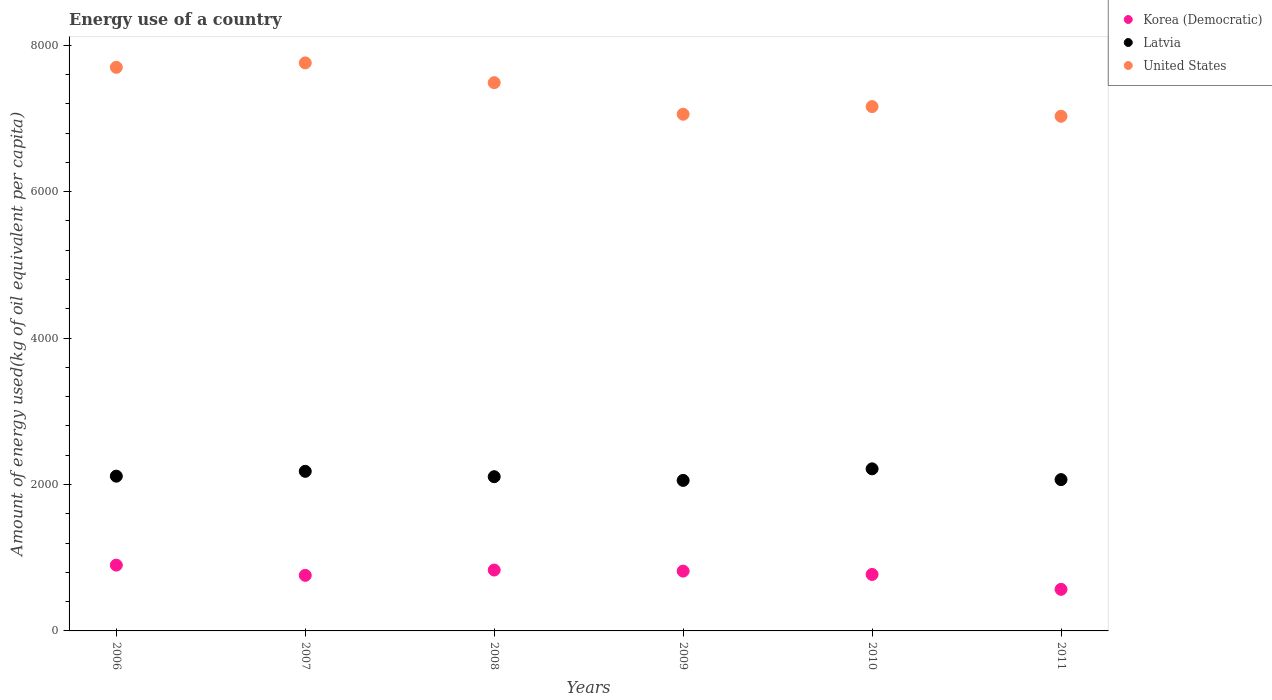What is the amount of energy used in in Korea (Democratic) in 2010?
Your response must be concise. 771.3. Across all years, what is the maximum amount of energy used in in United States?
Ensure brevity in your answer.  7758.17. Across all years, what is the minimum amount of energy used in in United States?
Keep it short and to the point. 7029.18. In which year was the amount of energy used in in Korea (Democratic) maximum?
Ensure brevity in your answer.  2006. What is the total amount of energy used in in Latvia in the graph?
Ensure brevity in your answer.  1.27e+04. What is the difference between the amount of energy used in in Latvia in 2009 and that in 2010?
Ensure brevity in your answer.  -157.81. What is the difference between the amount of energy used in in United States in 2008 and the amount of energy used in in Latvia in 2010?
Offer a terse response. 5274.44. What is the average amount of energy used in in Latvia per year?
Your answer should be compact. 2122.66. In the year 2008, what is the difference between the amount of energy used in in Latvia and amount of energy used in in Korea (Democratic)?
Your response must be concise. 1274.65. In how many years, is the amount of energy used in in Latvia greater than 4400 kg?
Your answer should be very brief. 0. What is the ratio of the amount of energy used in in Korea (Democratic) in 2006 to that in 2010?
Keep it short and to the point. 1.17. What is the difference between the highest and the second highest amount of energy used in in Latvia?
Your answer should be compact. 33.82. What is the difference between the highest and the lowest amount of energy used in in United States?
Offer a terse response. 728.98. In how many years, is the amount of energy used in in Korea (Democratic) greater than the average amount of energy used in in Korea (Democratic) taken over all years?
Keep it short and to the point. 3. Is the sum of the amount of energy used in in Korea (Democratic) in 2006 and 2009 greater than the maximum amount of energy used in in Latvia across all years?
Your response must be concise. No. Is it the case that in every year, the sum of the amount of energy used in in United States and amount of energy used in in Korea (Democratic)  is greater than the amount of energy used in in Latvia?
Provide a short and direct response. Yes. Does the amount of energy used in in Latvia monotonically increase over the years?
Keep it short and to the point. No. How many years are there in the graph?
Offer a terse response. 6. Does the graph contain any zero values?
Your answer should be compact. No. Where does the legend appear in the graph?
Your answer should be very brief. Top right. What is the title of the graph?
Keep it short and to the point. Energy use of a country. What is the label or title of the Y-axis?
Offer a terse response. Amount of energy used(kg of oil equivalent per capita). What is the Amount of energy used(kg of oil equivalent per capita) of Korea (Democratic) in 2006?
Make the answer very short. 898.79. What is the Amount of energy used(kg of oil equivalent per capita) in Latvia in 2006?
Your answer should be compact. 2113.71. What is the Amount of energy used(kg of oil equivalent per capita) of United States in 2006?
Provide a short and direct response. 7697.65. What is the Amount of energy used(kg of oil equivalent per capita) in Korea (Democratic) in 2007?
Offer a terse response. 758.95. What is the Amount of energy used(kg of oil equivalent per capita) of Latvia in 2007?
Ensure brevity in your answer.  2179.81. What is the Amount of energy used(kg of oil equivalent per capita) in United States in 2007?
Your answer should be very brief. 7758.17. What is the Amount of energy used(kg of oil equivalent per capita) in Korea (Democratic) in 2008?
Your response must be concise. 831.71. What is the Amount of energy used(kg of oil equivalent per capita) in Latvia in 2008?
Offer a very short reply. 2106.36. What is the Amount of energy used(kg of oil equivalent per capita) in United States in 2008?
Give a very brief answer. 7488.08. What is the Amount of energy used(kg of oil equivalent per capita) of Korea (Democratic) in 2009?
Your answer should be compact. 816.96. What is the Amount of energy used(kg of oil equivalent per capita) of Latvia in 2009?
Provide a short and direct response. 2055.82. What is the Amount of energy used(kg of oil equivalent per capita) in United States in 2009?
Ensure brevity in your answer.  7056.78. What is the Amount of energy used(kg of oil equivalent per capita) of Korea (Democratic) in 2010?
Provide a succinct answer. 771.3. What is the Amount of energy used(kg of oil equivalent per capita) of Latvia in 2010?
Make the answer very short. 2213.64. What is the Amount of energy used(kg of oil equivalent per capita) of United States in 2010?
Offer a terse response. 7161.51. What is the Amount of energy used(kg of oil equivalent per capita) in Korea (Democratic) in 2011?
Your answer should be very brief. 567.92. What is the Amount of energy used(kg of oil equivalent per capita) of Latvia in 2011?
Provide a succinct answer. 2066.64. What is the Amount of energy used(kg of oil equivalent per capita) in United States in 2011?
Your answer should be very brief. 7029.18. Across all years, what is the maximum Amount of energy used(kg of oil equivalent per capita) in Korea (Democratic)?
Your response must be concise. 898.79. Across all years, what is the maximum Amount of energy used(kg of oil equivalent per capita) of Latvia?
Your answer should be very brief. 2213.64. Across all years, what is the maximum Amount of energy used(kg of oil equivalent per capita) in United States?
Your response must be concise. 7758.17. Across all years, what is the minimum Amount of energy used(kg of oil equivalent per capita) of Korea (Democratic)?
Provide a short and direct response. 567.92. Across all years, what is the minimum Amount of energy used(kg of oil equivalent per capita) of Latvia?
Keep it short and to the point. 2055.82. Across all years, what is the minimum Amount of energy used(kg of oil equivalent per capita) in United States?
Your response must be concise. 7029.18. What is the total Amount of energy used(kg of oil equivalent per capita) in Korea (Democratic) in the graph?
Provide a succinct answer. 4645.62. What is the total Amount of energy used(kg of oil equivalent per capita) of Latvia in the graph?
Keep it short and to the point. 1.27e+04. What is the total Amount of energy used(kg of oil equivalent per capita) in United States in the graph?
Make the answer very short. 4.42e+04. What is the difference between the Amount of energy used(kg of oil equivalent per capita) in Korea (Democratic) in 2006 and that in 2007?
Provide a succinct answer. 139.85. What is the difference between the Amount of energy used(kg of oil equivalent per capita) of Latvia in 2006 and that in 2007?
Provide a succinct answer. -66.1. What is the difference between the Amount of energy used(kg of oil equivalent per capita) in United States in 2006 and that in 2007?
Give a very brief answer. -60.51. What is the difference between the Amount of energy used(kg of oil equivalent per capita) in Korea (Democratic) in 2006 and that in 2008?
Offer a very short reply. 67.08. What is the difference between the Amount of energy used(kg of oil equivalent per capita) of Latvia in 2006 and that in 2008?
Provide a short and direct response. 7.35. What is the difference between the Amount of energy used(kg of oil equivalent per capita) in United States in 2006 and that in 2008?
Keep it short and to the point. 209.57. What is the difference between the Amount of energy used(kg of oil equivalent per capita) in Korea (Democratic) in 2006 and that in 2009?
Provide a succinct answer. 81.83. What is the difference between the Amount of energy used(kg of oil equivalent per capita) of Latvia in 2006 and that in 2009?
Your answer should be compact. 57.89. What is the difference between the Amount of energy used(kg of oil equivalent per capita) in United States in 2006 and that in 2009?
Your answer should be compact. 640.88. What is the difference between the Amount of energy used(kg of oil equivalent per capita) in Korea (Democratic) in 2006 and that in 2010?
Provide a succinct answer. 127.5. What is the difference between the Amount of energy used(kg of oil equivalent per capita) in Latvia in 2006 and that in 2010?
Make the answer very short. -99.93. What is the difference between the Amount of energy used(kg of oil equivalent per capita) of United States in 2006 and that in 2010?
Offer a very short reply. 536.14. What is the difference between the Amount of energy used(kg of oil equivalent per capita) in Korea (Democratic) in 2006 and that in 2011?
Give a very brief answer. 330.88. What is the difference between the Amount of energy used(kg of oil equivalent per capita) of Latvia in 2006 and that in 2011?
Your answer should be very brief. 47.07. What is the difference between the Amount of energy used(kg of oil equivalent per capita) of United States in 2006 and that in 2011?
Offer a very short reply. 668.47. What is the difference between the Amount of energy used(kg of oil equivalent per capita) of Korea (Democratic) in 2007 and that in 2008?
Ensure brevity in your answer.  -72.77. What is the difference between the Amount of energy used(kg of oil equivalent per capita) in Latvia in 2007 and that in 2008?
Provide a short and direct response. 73.45. What is the difference between the Amount of energy used(kg of oil equivalent per capita) of United States in 2007 and that in 2008?
Your answer should be very brief. 270.08. What is the difference between the Amount of energy used(kg of oil equivalent per capita) of Korea (Democratic) in 2007 and that in 2009?
Provide a short and direct response. -58.02. What is the difference between the Amount of energy used(kg of oil equivalent per capita) in Latvia in 2007 and that in 2009?
Keep it short and to the point. 123.99. What is the difference between the Amount of energy used(kg of oil equivalent per capita) in United States in 2007 and that in 2009?
Your answer should be very brief. 701.39. What is the difference between the Amount of energy used(kg of oil equivalent per capita) in Korea (Democratic) in 2007 and that in 2010?
Offer a terse response. -12.35. What is the difference between the Amount of energy used(kg of oil equivalent per capita) of Latvia in 2007 and that in 2010?
Provide a succinct answer. -33.82. What is the difference between the Amount of energy used(kg of oil equivalent per capita) in United States in 2007 and that in 2010?
Your answer should be very brief. 596.65. What is the difference between the Amount of energy used(kg of oil equivalent per capita) of Korea (Democratic) in 2007 and that in 2011?
Offer a very short reply. 191.03. What is the difference between the Amount of energy used(kg of oil equivalent per capita) of Latvia in 2007 and that in 2011?
Your answer should be very brief. 113.18. What is the difference between the Amount of energy used(kg of oil equivalent per capita) of United States in 2007 and that in 2011?
Ensure brevity in your answer.  728.98. What is the difference between the Amount of energy used(kg of oil equivalent per capita) of Korea (Democratic) in 2008 and that in 2009?
Your response must be concise. 14.75. What is the difference between the Amount of energy used(kg of oil equivalent per capita) of Latvia in 2008 and that in 2009?
Offer a very short reply. 50.54. What is the difference between the Amount of energy used(kg of oil equivalent per capita) in United States in 2008 and that in 2009?
Provide a succinct answer. 431.3. What is the difference between the Amount of energy used(kg of oil equivalent per capita) in Korea (Democratic) in 2008 and that in 2010?
Provide a short and direct response. 60.42. What is the difference between the Amount of energy used(kg of oil equivalent per capita) in Latvia in 2008 and that in 2010?
Keep it short and to the point. -107.27. What is the difference between the Amount of energy used(kg of oil equivalent per capita) in United States in 2008 and that in 2010?
Give a very brief answer. 326.57. What is the difference between the Amount of energy used(kg of oil equivalent per capita) in Korea (Democratic) in 2008 and that in 2011?
Keep it short and to the point. 263.79. What is the difference between the Amount of energy used(kg of oil equivalent per capita) in Latvia in 2008 and that in 2011?
Your answer should be very brief. 39.73. What is the difference between the Amount of energy used(kg of oil equivalent per capita) in United States in 2008 and that in 2011?
Keep it short and to the point. 458.9. What is the difference between the Amount of energy used(kg of oil equivalent per capita) in Korea (Democratic) in 2009 and that in 2010?
Keep it short and to the point. 45.67. What is the difference between the Amount of energy used(kg of oil equivalent per capita) in Latvia in 2009 and that in 2010?
Offer a very short reply. -157.81. What is the difference between the Amount of energy used(kg of oil equivalent per capita) in United States in 2009 and that in 2010?
Provide a short and direct response. -104.74. What is the difference between the Amount of energy used(kg of oil equivalent per capita) in Korea (Democratic) in 2009 and that in 2011?
Provide a succinct answer. 249.05. What is the difference between the Amount of energy used(kg of oil equivalent per capita) in Latvia in 2009 and that in 2011?
Your response must be concise. -10.81. What is the difference between the Amount of energy used(kg of oil equivalent per capita) in United States in 2009 and that in 2011?
Your answer should be very brief. 27.59. What is the difference between the Amount of energy used(kg of oil equivalent per capita) in Korea (Democratic) in 2010 and that in 2011?
Your response must be concise. 203.38. What is the difference between the Amount of energy used(kg of oil equivalent per capita) in Latvia in 2010 and that in 2011?
Provide a succinct answer. 147. What is the difference between the Amount of energy used(kg of oil equivalent per capita) in United States in 2010 and that in 2011?
Your answer should be very brief. 132.33. What is the difference between the Amount of energy used(kg of oil equivalent per capita) of Korea (Democratic) in 2006 and the Amount of energy used(kg of oil equivalent per capita) of Latvia in 2007?
Provide a short and direct response. -1281.02. What is the difference between the Amount of energy used(kg of oil equivalent per capita) in Korea (Democratic) in 2006 and the Amount of energy used(kg of oil equivalent per capita) in United States in 2007?
Your answer should be very brief. -6859.37. What is the difference between the Amount of energy used(kg of oil equivalent per capita) in Latvia in 2006 and the Amount of energy used(kg of oil equivalent per capita) in United States in 2007?
Provide a short and direct response. -5644.45. What is the difference between the Amount of energy used(kg of oil equivalent per capita) of Korea (Democratic) in 2006 and the Amount of energy used(kg of oil equivalent per capita) of Latvia in 2008?
Your response must be concise. -1207.57. What is the difference between the Amount of energy used(kg of oil equivalent per capita) of Korea (Democratic) in 2006 and the Amount of energy used(kg of oil equivalent per capita) of United States in 2008?
Offer a very short reply. -6589.29. What is the difference between the Amount of energy used(kg of oil equivalent per capita) in Latvia in 2006 and the Amount of energy used(kg of oil equivalent per capita) in United States in 2008?
Make the answer very short. -5374.37. What is the difference between the Amount of energy used(kg of oil equivalent per capita) in Korea (Democratic) in 2006 and the Amount of energy used(kg of oil equivalent per capita) in Latvia in 2009?
Your answer should be compact. -1157.03. What is the difference between the Amount of energy used(kg of oil equivalent per capita) in Korea (Democratic) in 2006 and the Amount of energy used(kg of oil equivalent per capita) in United States in 2009?
Provide a short and direct response. -6157.98. What is the difference between the Amount of energy used(kg of oil equivalent per capita) in Latvia in 2006 and the Amount of energy used(kg of oil equivalent per capita) in United States in 2009?
Your response must be concise. -4943.07. What is the difference between the Amount of energy used(kg of oil equivalent per capita) in Korea (Democratic) in 2006 and the Amount of energy used(kg of oil equivalent per capita) in Latvia in 2010?
Offer a terse response. -1314.85. What is the difference between the Amount of energy used(kg of oil equivalent per capita) of Korea (Democratic) in 2006 and the Amount of energy used(kg of oil equivalent per capita) of United States in 2010?
Your response must be concise. -6262.72. What is the difference between the Amount of energy used(kg of oil equivalent per capita) in Latvia in 2006 and the Amount of energy used(kg of oil equivalent per capita) in United States in 2010?
Offer a terse response. -5047.8. What is the difference between the Amount of energy used(kg of oil equivalent per capita) in Korea (Democratic) in 2006 and the Amount of energy used(kg of oil equivalent per capita) in Latvia in 2011?
Your answer should be compact. -1167.84. What is the difference between the Amount of energy used(kg of oil equivalent per capita) in Korea (Democratic) in 2006 and the Amount of energy used(kg of oil equivalent per capita) in United States in 2011?
Ensure brevity in your answer.  -6130.39. What is the difference between the Amount of energy used(kg of oil equivalent per capita) of Latvia in 2006 and the Amount of energy used(kg of oil equivalent per capita) of United States in 2011?
Offer a terse response. -4915.47. What is the difference between the Amount of energy used(kg of oil equivalent per capita) in Korea (Democratic) in 2007 and the Amount of energy used(kg of oil equivalent per capita) in Latvia in 2008?
Offer a very short reply. -1347.42. What is the difference between the Amount of energy used(kg of oil equivalent per capita) in Korea (Democratic) in 2007 and the Amount of energy used(kg of oil equivalent per capita) in United States in 2008?
Your response must be concise. -6729.14. What is the difference between the Amount of energy used(kg of oil equivalent per capita) of Latvia in 2007 and the Amount of energy used(kg of oil equivalent per capita) of United States in 2008?
Provide a short and direct response. -5308.27. What is the difference between the Amount of energy used(kg of oil equivalent per capita) in Korea (Democratic) in 2007 and the Amount of energy used(kg of oil equivalent per capita) in Latvia in 2009?
Give a very brief answer. -1296.88. What is the difference between the Amount of energy used(kg of oil equivalent per capita) in Korea (Democratic) in 2007 and the Amount of energy used(kg of oil equivalent per capita) in United States in 2009?
Make the answer very short. -6297.83. What is the difference between the Amount of energy used(kg of oil equivalent per capita) in Latvia in 2007 and the Amount of energy used(kg of oil equivalent per capita) in United States in 2009?
Offer a very short reply. -4876.96. What is the difference between the Amount of energy used(kg of oil equivalent per capita) in Korea (Democratic) in 2007 and the Amount of energy used(kg of oil equivalent per capita) in Latvia in 2010?
Your answer should be compact. -1454.69. What is the difference between the Amount of energy used(kg of oil equivalent per capita) of Korea (Democratic) in 2007 and the Amount of energy used(kg of oil equivalent per capita) of United States in 2010?
Give a very brief answer. -6402.57. What is the difference between the Amount of energy used(kg of oil equivalent per capita) in Latvia in 2007 and the Amount of energy used(kg of oil equivalent per capita) in United States in 2010?
Offer a terse response. -4981.7. What is the difference between the Amount of energy used(kg of oil equivalent per capita) in Korea (Democratic) in 2007 and the Amount of energy used(kg of oil equivalent per capita) in Latvia in 2011?
Your answer should be very brief. -1307.69. What is the difference between the Amount of energy used(kg of oil equivalent per capita) of Korea (Democratic) in 2007 and the Amount of energy used(kg of oil equivalent per capita) of United States in 2011?
Make the answer very short. -6270.24. What is the difference between the Amount of energy used(kg of oil equivalent per capita) in Latvia in 2007 and the Amount of energy used(kg of oil equivalent per capita) in United States in 2011?
Ensure brevity in your answer.  -4849.37. What is the difference between the Amount of energy used(kg of oil equivalent per capita) of Korea (Democratic) in 2008 and the Amount of energy used(kg of oil equivalent per capita) of Latvia in 2009?
Offer a very short reply. -1224.11. What is the difference between the Amount of energy used(kg of oil equivalent per capita) of Korea (Democratic) in 2008 and the Amount of energy used(kg of oil equivalent per capita) of United States in 2009?
Offer a terse response. -6225.07. What is the difference between the Amount of energy used(kg of oil equivalent per capita) in Latvia in 2008 and the Amount of energy used(kg of oil equivalent per capita) in United States in 2009?
Your answer should be very brief. -4950.41. What is the difference between the Amount of energy used(kg of oil equivalent per capita) of Korea (Democratic) in 2008 and the Amount of energy used(kg of oil equivalent per capita) of Latvia in 2010?
Ensure brevity in your answer.  -1381.93. What is the difference between the Amount of energy used(kg of oil equivalent per capita) in Korea (Democratic) in 2008 and the Amount of energy used(kg of oil equivalent per capita) in United States in 2010?
Offer a terse response. -6329.8. What is the difference between the Amount of energy used(kg of oil equivalent per capita) of Latvia in 2008 and the Amount of energy used(kg of oil equivalent per capita) of United States in 2010?
Offer a terse response. -5055.15. What is the difference between the Amount of energy used(kg of oil equivalent per capita) in Korea (Democratic) in 2008 and the Amount of energy used(kg of oil equivalent per capita) in Latvia in 2011?
Provide a succinct answer. -1234.93. What is the difference between the Amount of energy used(kg of oil equivalent per capita) of Korea (Democratic) in 2008 and the Amount of energy used(kg of oil equivalent per capita) of United States in 2011?
Your response must be concise. -6197.47. What is the difference between the Amount of energy used(kg of oil equivalent per capita) of Latvia in 2008 and the Amount of energy used(kg of oil equivalent per capita) of United States in 2011?
Your answer should be compact. -4922.82. What is the difference between the Amount of energy used(kg of oil equivalent per capita) of Korea (Democratic) in 2009 and the Amount of energy used(kg of oil equivalent per capita) of Latvia in 2010?
Offer a terse response. -1396.67. What is the difference between the Amount of energy used(kg of oil equivalent per capita) in Korea (Democratic) in 2009 and the Amount of energy used(kg of oil equivalent per capita) in United States in 2010?
Give a very brief answer. -6344.55. What is the difference between the Amount of energy used(kg of oil equivalent per capita) in Latvia in 2009 and the Amount of energy used(kg of oil equivalent per capita) in United States in 2010?
Provide a short and direct response. -5105.69. What is the difference between the Amount of energy used(kg of oil equivalent per capita) of Korea (Democratic) in 2009 and the Amount of energy used(kg of oil equivalent per capita) of Latvia in 2011?
Make the answer very short. -1249.67. What is the difference between the Amount of energy used(kg of oil equivalent per capita) of Korea (Democratic) in 2009 and the Amount of energy used(kg of oil equivalent per capita) of United States in 2011?
Provide a succinct answer. -6212.22. What is the difference between the Amount of energy used(kg of oil equivalent per capita) in Latvia in 2009 and the Amount of energy used(kg of oil equivalent per capita) in United States in 2011?
Provide a short and direct response. -4973.36. What is the difference between the Amount of energy used(kg of oil equivalent per capita) of Korea (Democratic) in 2010 and the Amount of energy used(kg of oil equivalent per capita) of Latvia in 2011?
Your response must be concise. -1295.34. What is the difference between the Amount of energy used(kg of oil equivalent per capita) of Korea (Democratic) in 2010 and the Amount of energy used(kg of oil equivalent per capita) of United States in 2011?
Your answer should be very brief. -6257.89. What is the difference between the Amount of energy used(kg of oil equivalent per capita) in Latvia in 2010 and the Amount of energy used(kg of oil equivalent per capita) in United States in 2011?
Ensure brevity in your answer.  -4815.55. What is the average Amount of energy used(kg of oil equivalent per capita) of Korea (Democratic) per year?
Offer a very short reply. 774.27. What is the average Amount of energy used(kg of oil equivalent per capita) of Latvia per year?
Ensure brevity in your answer.  2122.66. What is the average Amount of energy used(kg of oil equivalent per capita) of United States per year?
Keep it short and to the point. 7365.23. In the year 2006, what is the difference between the Amount of energy used(kg of oil equivalent per capita) of Korea (Democratic) and Amount of energy used(kg of oil equivalent per capita) of Latvia?
Offer a very short reply. -1214.92. In the year 2006, what is the difference between the Amount of energy used(kg of oil equivalent per capita) in Korea (Democratic) and Amount of energy used(kg of oil equivalent per capita) in United States?
Your response must be concise. -6798.86. In the year 2006, what is the difference between the Amount of energy used(kg of oil equivalent per capita) of Latvia and Amount of energy used(kg of oil equivalent per capita) of United States?
Offer a very short reply. -5583.94. In the year 2007, what is the difference between the Amount of energy used(kg of oil equivalent per capita) in Korea (Democratic) and Amount of energy used(kg of oil equivalent per capita) in Latvia?
Ensure brevity in your answer.  -1420.87. In the year 2007, what is the difference between the Amount of energy used(kg of oil equivalent per capita) in Korea (Democratic) and Amount of energy used(kg of oil equivalent per capita) in United States?
Make the answer very short. -6999.22. In the year 2007, what is the difference between the Amount of energy used(kg of oil equivalent per capita) of Latvia and Amount of energy used(kg of oil equivalent per capita) of United States?
Ensure brevity in your answer.  -5578.35. In the year 2008, what is the difference between the Amount of energy used(kg of oil equivalent per capita) of Korea (Democratic) and Amount of energy used(kg of oil equivalent per capita) of Latvia?
Ensure brevity in your answer.  -1274.65. In the year 2008, what is the difference between the Amount of energy used(kg of oil equivalent per capita) of Korea (Democratic) and Amount of energy used(kg of oil equivalent per capita) of United States?
Offer a terse response. -6656.37. In the year 2008, what is the difference between the Amount of energy used(kg of oil equivalent per capita) in Latvia and Amount of energy used(kg of oil equivalent per capita) in United States?
Provide a succinct answer. -5381.72. In the year 2009, what is the difference between the Amount of energy used(kg of oil equivalent per capita) in Korea (Democratic) and Amount of energy used(kg of oil equivalent per capita) in Latvia?
Your answer should be very brief. -1238.86. In the year 2009, what is the difference between the Amount of energy used(kg of oil equivalent per capita) in Korea (Democratic) and Amount of energy used(kg of oil equivalent per capita) in United States?
Ensure brevity in your answer.  -6239.81. In the year 2009, what is the difference between the Amount of energy used(kg of oil equivalent per capita) in Latvia and Amount of energy used(kg of oil equivalent per capita) in United States?
Give a very brief answer. -5000.95. In the year 2010, what is the difference between the Amount of energy used(kg of oil equivalent per capita) of Korea (Democratic) and Amount of energy used(kg of oil equivalent per capita) of Latvia?
Offer a very short reply. -1442.34. In the year 2010, what is the difference between the Amount of energy used(kg of oil equivalent per capita) in Korea (Democratic) and Amount of energy used(kg of oil equivalent per capita) in United States?
Offer a terse response. -6390.22. In the year 2010, what is the difference between the Amount of energy used(kg of oil equivalent per capita) of Latvia and Amount of energy used(kg of oil equivalent per capita) of United States?
Provide a short and direct response. -4947.87. In the year 2011, what is the difference between the Amount of energy used(kg of oil equivalent per capita) in Korea (Democratic) and Amount of energy used(kg of oil equivalent per capita) in Latvia?
Provide a succinct answer. -1498.72. In the year 2011, what is the difference between the Amount of energy used(kg of oil equivalent per capita) of Korea (Democratic) and Amount of energy used(kg of oil equivalent per capita) of United States?
Your answer should be compact. -6461.27. In the year 2011, what is the difference between the Amount of energy used(kg of oil equivalent per capita) in Latvia and Amount of energy used(kg of oil equivalent per capita) in United States?
Your response must be concise. -4962.55. What is the ratio of the Amount of energy used(kg of oil equivalent per capita) of Korea (Democratic) in 2006 to that in 2007?
Give a very brief answer. 1.18. What is the ratio of the Amount of energy used(kg of oil equivalent per capita) of Latvia in 2006 to that in 2007?
Keep it short and to the point. 0.97. What is the ratio of the Amount of energy used(kg of oil equivalent per capita) of Korea (Democratic) in 2006 to that in 2008?
Your response must be concise. 1.08. What is the ratio of the Amount of energy used(kg of oil equivalent per capita) of Latvia in 2006 to that in 2008?
Give a very brief answer. 1. What is the ratio of the Amount of energy used(kg of oil equivalent per capita) in United States in 2006 to that in 2008?
Provide a succinct answer. 1.03. What is the ratio of the Amount of energy used(kg of oil equivalent per capita) of Korea (Democratic) in 2006 to that in 2009?
Ensure brevity in your answer.  1.1. What is the ratio of the Amount of energy used(kg of oil equivalent per capita) in Latvia in 2006 to that in 2009?
Make the answer very short. 1.03. What is the ratio of the Amount of energy used(kg of oil equivalent per capita) in United States in 2006 to that in 2009?
Offer a terse response. 1.09. What is the ratio of the Amount of energy used(kg of oil equivalent per capita) of Korea (Democratic) in 2006 to that in 2010?
Your response must be concise. 1.17. What is the ratio of the Amount of energy used(kg of oil equivalent per capita) in Latvia in 2006 to that in 2010?
Give a very brief answer. 0.95. What is the ratio of the Amount of energy used(kg of oil equivalent per capita) in United States in 2006 to that in 2010?
Your response must be concise. 1.07. What is the ratio of the Amount of energy used(kg of oil equivalent per capita) of Korea (Democratic) in 2006 to that in 2011?
Offer a terse response. 1.58. What is the ratio of the Amount of energy used(kg of oil equivalent per capita) in Latvia in 2006 to that in 2011?
Keep it short and to the point. 1.02. What is the ratio of the Amount of energy used(kg of oil equivalent per capita) of United States in 2006 to that in 2011?
Provide a short and direct response. 1.1. What is the ratio of the Amount of energy used(kg of oil equivalent per capita) in Korea (Democratic) in 2007 to that in 2008?
Provide a short and direct response. 0.91. What is the ratio of the Amount of energy used(kg of oil equivalent per capita) in Latvia in 2007 to that in 2008?
Your answer should be compact. 1.03. What is the ratio of the Amount of energy used(kg of oil equivalent per capita) of United States in 2007 to that in 2008?
Provide a short and direct response. 1.04. What is the ratio of the Amount of energy used(kg of oil equivalent per capita) of Korea (Democratic) in 2007 to that in 2009?
Offer a terse response. 0.93. What is the ratio of the Amount of energy used(kg of oil equivalent per capita) of Latvia in 2007 to that in 2009?
Provide a succinct answer. 1.06. What is the ratio of the Amount of energy used(kg of oil equivalent per capita) of United States in 2007 to that in 2009?
Provide a short and direct response. 1.1. What is the ratio of the Amount of energy used(kg of oil equivalent per capita) of Korea (Democratic) in 2007 to that in 2010?
Your response must be concise. 0.98. What is the ratio of the Amount of energy used(kg of oil equivalent per capita) of Latvia in 2007 to that in 2010?
Make the answer very short. 0.98. What is the ratio of the Amount of energy used(kg of oil equivalent per capita) in Korea (Democratic) in 2007 to that in 2011?
Keep it short and to the point. 1.34. What is the ratio of the Amount of energy used(kg of oil equivalent per capita) in Latvia in 2007 to that in 2011?
Your answer should be very brief. 1.05. What is the ratio of the Amount of energy used(kg of oil equivalent per capita) in United States in 2007 to that in 2011?
Offer a terse response. 1.1. What is the ratio of the Amount of energy used(kg of oil equivalent per capita) of Korea (Democratic) in 2008 to that in 2009?
Your answer should be very brief. 1.02. What is the ratio of the Amount of energy used(kg of oil equivalent per capita) of Latvia in 2008 to that in 2009?
Give a very brief answer. 1.02. What is the ratio of the Amount of energy used(kg of oil equivalent per capita) of United States in 2008 to that in 2009?
Provide a succinct answer. 1.06. What is the ratio of the Amount of energy used(kg of oil equivalent per capita) of Korea (Democratic) in 2008 to that in 2010?
Keep it short and to the point. 1.08. What is the ratio of the Amount of energy used(kg of oil equivalent per capita) of Latvia in 2008 to that in 2010?
Offer a terse response. 0.95. What is the ratio of the Amount of energy used(kg of oil equivalent per capita) in United States in 2008 to that in 2010?
Ensure brevity in your answer.  1.05. What is the ratio of the Amount of energy used(kg of oil equivalent per capita) in Korea (Democratic) in 2008 to that in 2011?
Keep it short and to the point. 1.46. What is the ratio of the Amount of energy used(kg of oil equivalent per capita) of Latvia in 2008 to that in 2011?
Give a very brief answer. 1.02. What is the ratio of the Amount of energy used(kg of oil equivalent per capita) of United States in 2008 to that in 2011?
Your answer should be compact. 1.07. What is the ratio of the Amount of energy used(kg of oil equivalent per capita) in Korea (Democratic) in 2009 to that in 2010?
Your answer should be very brief. 1.06. What is the ratio of the Amount of energy used(kg of oil equivalent per capita) of Latvia in 2009 to that in 2010?
Provide a short and direct response. 0.93. What is the ratio of the Amount of energy used(kg of oil equivalent per capita) in United States in 2009 to that in 2010?
Your answer should be very brief. 0.99. What is the ratio of the Amount of energy used(kg of oil equivalent per capita) of Korea (Democratic) in 2009 to that in 2011?
Your response must be concise. 1.44. What is the ratio of the Amount of energy used(kg of oil equivalent per capita) of United States in 2009 to that in 2011?
Give a very brief answer. 1. What is the ratio of the Amount of energy used(kg of oil equivalent per capita) in Korea (Democratic) in 2010 to that in 2011?
Give a very brief answer. 1.36. What is the ratio of the Amount of energy used(kg of oil equivalent per capita) of Latvia in 2010 to that in 2011?
Ensure brevity in your answer.  1.07. What is the ratio of the Amount of energy used(kg of oil equivalent per capita) in United States in 2010 to that in 2011?
Your answer should be very brief. 1.02. What is the difference between the highest and the second highest Amount of energy used(kg of oil equivalent per capita) of Korea (Democratic)?
Give a very brief answer. 67.08. What is the difference between the highest and the second highest Amount of energy used(kg of oil equivalent per capita) of Latvia?
Your answer should be very brief. 33.82. What is the difference between the highest and the second highest Amount of energy used(kg of oil equivalent per capita) in United States?
Provide a short and direct response. 60.51. What is the difference between the highest and the lowest Amount of energy used(kg of oil equivalent per capita) in Korea (Democratic)?
Your answer should be very brief. 330.88. What is the difference between the highest and the lowest Amount of energy used(kg of oil equivalent per capita) of Latvia?
Keep it short and to the point. 157.81. What is the difference between the highest and the lowest Amount of energy used(kg of oil equivalent per capita) in United States?
Your response must be concise. 728.98. 